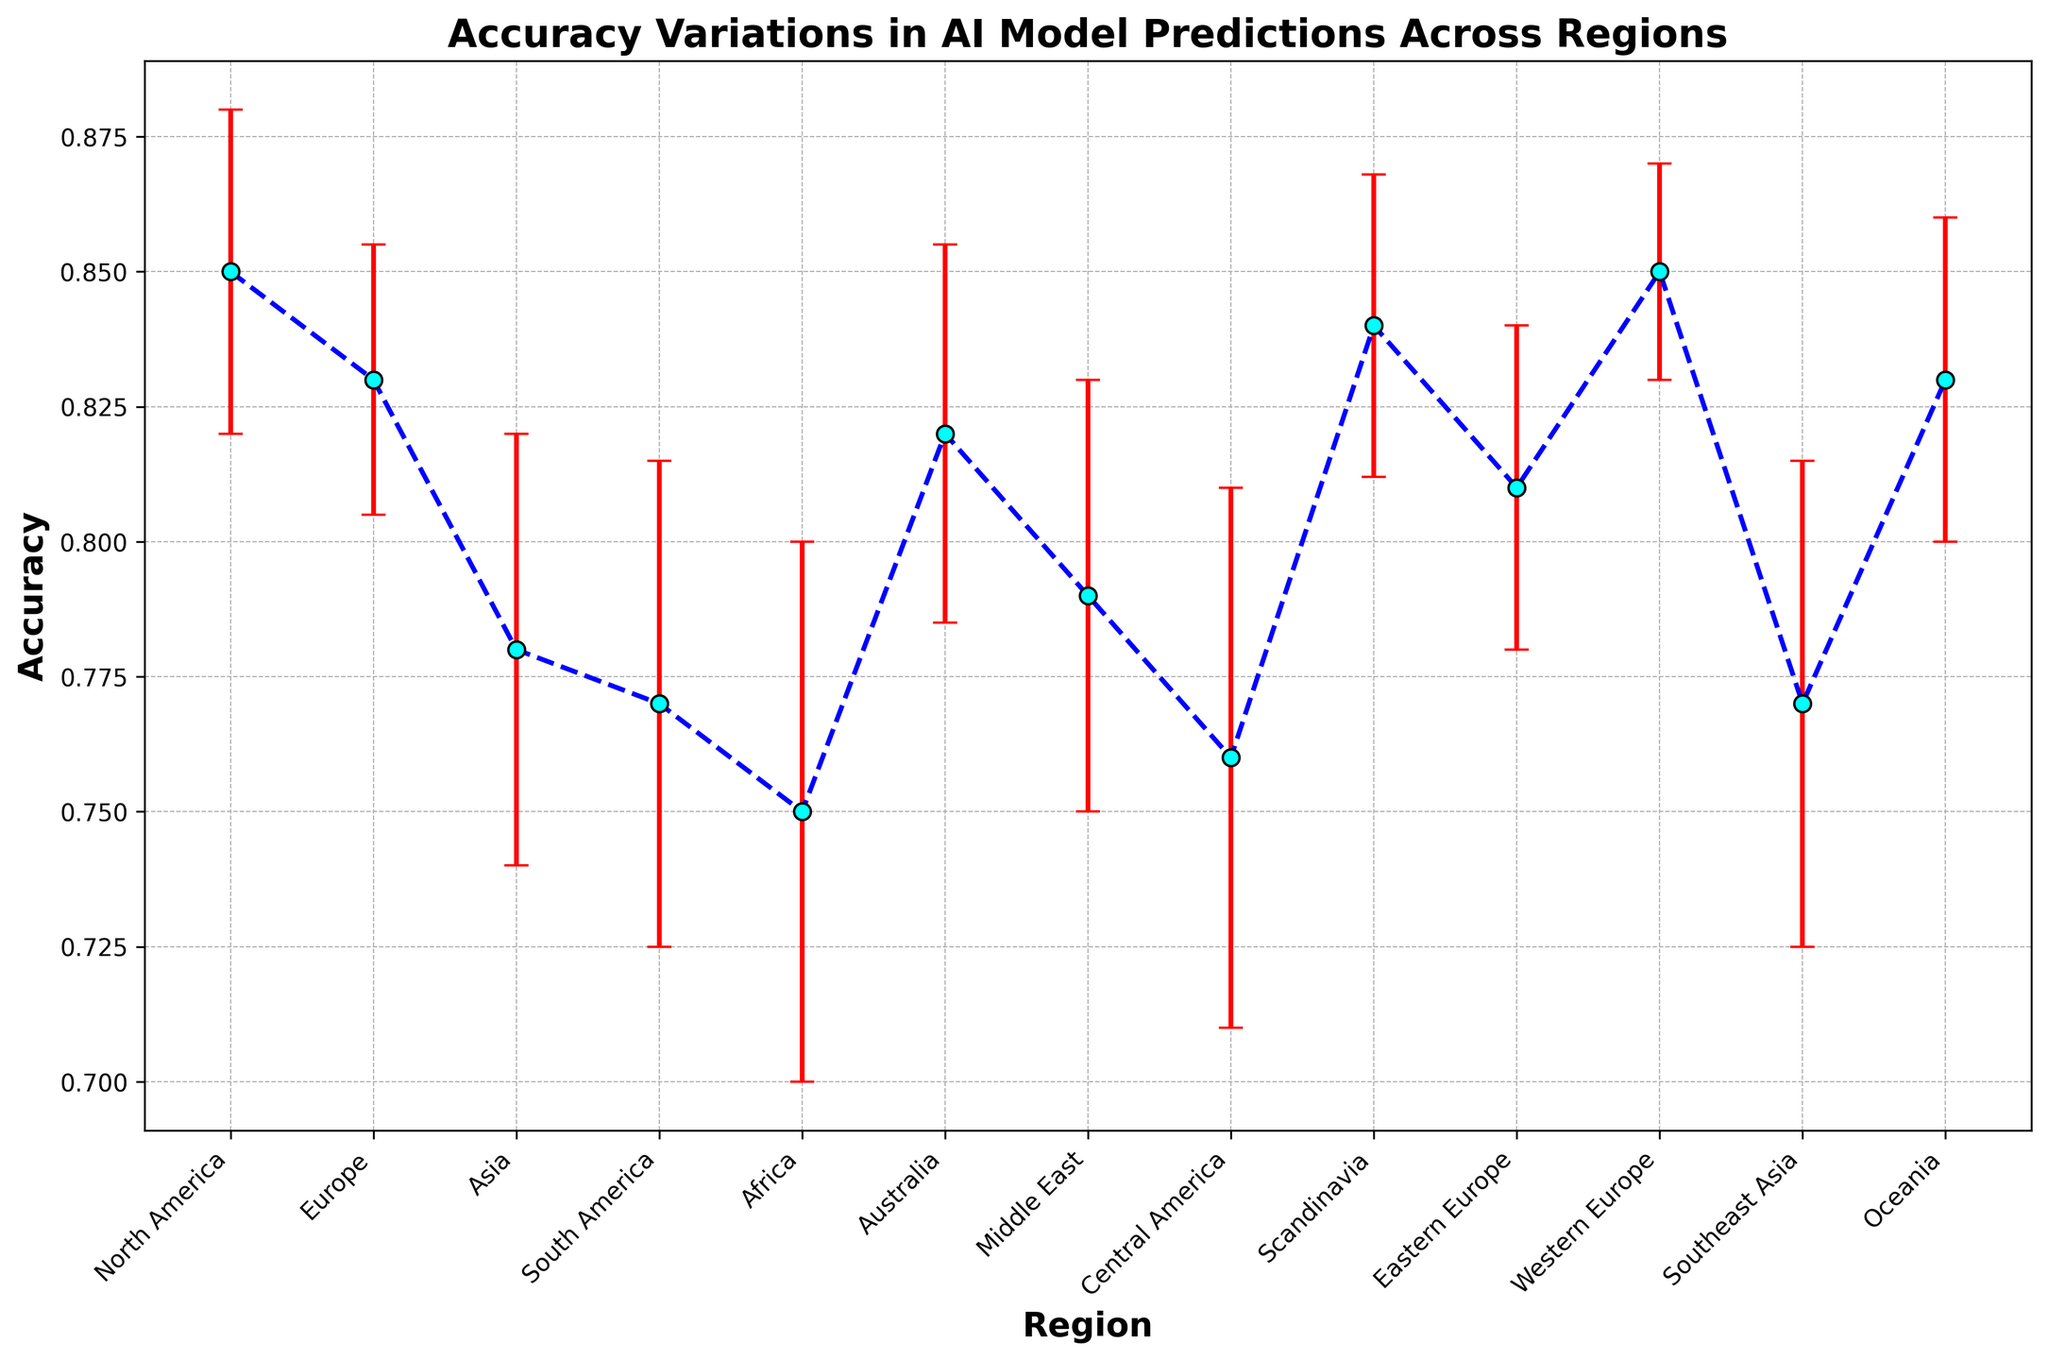Which region has the highest accuracy in AI model predictions? Looking at the plot, "North America" and "Western Europe" have the highest accuracy, both at 0.85.
Answer: North America and Western Europe Which region has the largest error margin? The region with the largest error margin can be seen by looking at the red error bars. "Africa" has the largest error margin at 0.05.
Answer: Africa What is the difference in accuracy between Asia and Europe? Asia's accuracy is 0.78, and Europe's average accuracy can be approximated by looking at both "Western Europe" which has 0.85 and "Eastern Europe" which has 0.81. For simplicity, take one of them, e.g., "Western Europe" with 0.85. So, the difference is 0.85 - 0.78 = 0.07.
Answer: 0.07 Which region has a lower accuracy, Scandinavia or Southeast Asia? Scandinavia has an accuracy of 0.84, while Southeast Asia has an accuracy of 0.77. Therefore, Southeast Asia has a lower accuracy.
Answer: Southeast Asia What is the average accuracy of the regions in the Southern Hemisphere (South America, Africa, Oceania)? The accuracies for South America, Africa, and Oceania are 0.77, 0.75, and 0.83 respectively. The average accuracy is (0.77 + 0.75 + 0.83) / 3 = 2.35 / 3 ≈ 0.7833.
Answer: 0.7833 Which regions have similar accuracy error margins? By observing the red error bars, "Asia" and "Middle East" both have error margins of 0.04.
Answer: Asia and Middle East How does the accuracy of Central America compare to that of Australia? Central America has an accuracy of 0.76, and Australia has an accuracy of 0.82. Therefore, Australia has a higher accuracy than Central America.
Answer: Australia What is the error margin difference between Africa and Australia? Africa's error margin is 0.05 and Australia's error margin is 0.035. The difference is 0.05 - 0.035 = 0.015.
Answer: 0.015 Which regions have an accuracy greater than 0.80? Looking at the figure, the regions with accuracies greater than 0.80 are North America, Western Europe, Scandinavia, Eastern Europe, and Oceania.
Answer: North America, Western Europe, Scandinavia, Eastern Europe, Oceania 